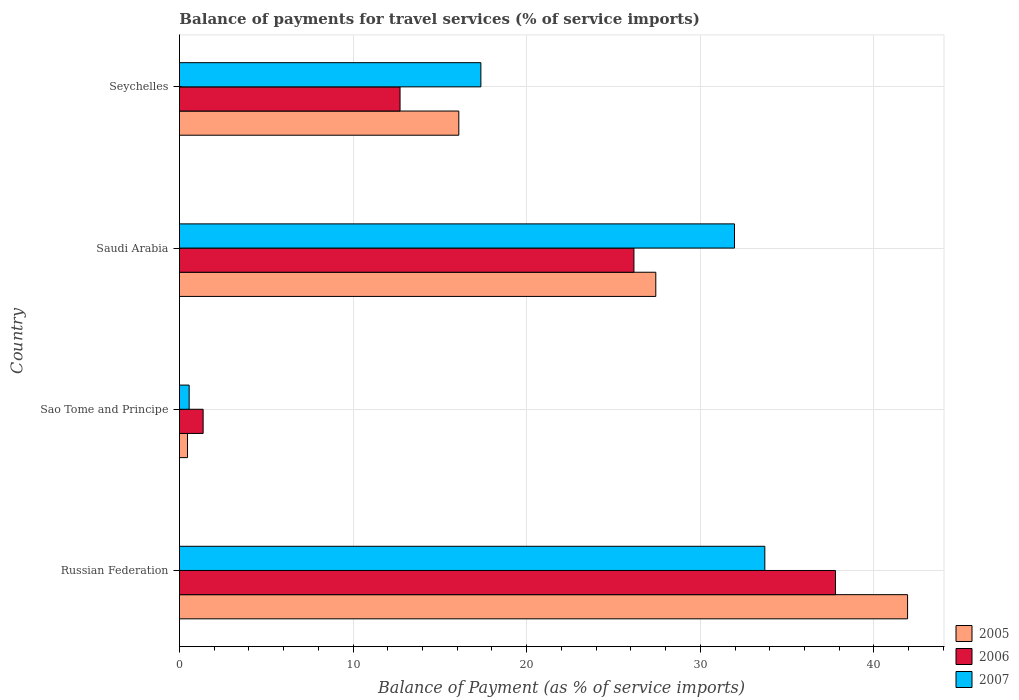How many groups of bars are there?
Keep it short and to the point. 4. Are the number of bars per tick equal to the number of legend labels?
Provide a short and direct response. Yes. Are the number of bars on each tick of the Y-axis equal?
Provide a succinct answer. Yes. How many bars are there on the 2nd tick from the top?
Offer a terse response. 3. How many bars are there on the 3rd tick from the bottom?
Ensure brevity in your answer.  3. What is the label of the 4th group of bars from the top?
Provide a succinct answer. Russian Federation. What is the balance of payments for travel services in 2006 in Russian Federation?
Ensure brevity in your answer.  37.78. Across all countries, what is the maximum balance of payments for travel services in 2007?
Ensure brevity in your answer.  33.72. Across all countries, what is the minimum balance of payments for travel services in 2005?
Make the answer very short. 0.47. In which country was the balance of payments for travel services in 2006 maximum?
Offer a terse response. Russian Federation. In which country was the balance of payments for travel services in 2007 minimum?
Provide a succinct answer. Sao Tome and Principe. What is the total balance of payments for travel services in 2006 in the graph?
Offer a very short reply. 78.03. What is the difference between the balance of payments for travel services in 2005 in Saudi Arabia and that in Seychelles?
Your answer should be compact. 11.34. What is the difference between the balance of payments for travel services in 2006 in Saudi Arabia and the balance of payments for travel services in 2007 in Sao Tome and Principe?
Your answer should be compact. 25.62. What is the average balance of payments for travel services in 2007 per country?
Your answer should be very brief. 20.9. What is the difference between the balance of payments for travel services in 2006 and balance of payments for travel services in 2005 in Sao Tome and Principe?
Your response must be concise. 0.9. In how many countries, is the balance of payments for travel services in 2007 greater than 26 %?
Keep it short and to the point. 2. What is the ratio of the balance of payments for travel services in 2007 in Saudi Arabia to that in Seychelles?
Your answer should be compact. 1.84. Is the balance of payments for travel services in 2006 in Russian Federation less than that in Seychelles?
Provide a short and direct response. No. Is the difference between the balance of payments for travel services in 2006 in Russian Federation and Sao Tome and Principe greater than the difference between the balance of payments for travel services in 2005 in Russian Federation and Sao Tome and Principe?
Keep it short and to the point. No. What is the difference between the highest and the second highest balance of payments for travel services in 2007?
Make the answer very short. 1.75. What is the difference between the highest and the lowest balance of payments for travel services in 2007?
Provide a short and direct response. 33.15. What does the 2nd bar from the top in Sao Tome and Principe represents?
Offer a very short reply. 2006. What does the 1st bar from the bottom in Russian Federation represents?
Give a very brief answer. 2005. Is it the case that in every country, the sum of the balance of payments for travel services in 2005 and balance of payments for travel services in 2007 is greater than the balance of payments for travel services in 2006?
Your answer should be very brief. No. How many bars are there?
Ensure brevity in your answer.  12. Are all the bars in the graph horizontal?
Your response must be concise. Yes. How many countries are there in the graph?
Ensure brevity in your answer.  4. Does the graph contain grids?
Provide a succinct answer. Yes. How are the legend labels stacked?
Make the answer very short. Vertical. What is the title of the graph?
Keep it short and to the point. Balance of payments for travel services (% of service imports). What is the label or title of the X-axis?
Give a very brief answer. Balance of Payment (as % of service imports). What is the Balance of Payment (as % of service imports) in 2005 in Russian Federation?
Provide a short and direct response. 41.94. What is the Balance of Payment (as % of service imports) in 2006 in Russian Federation?
Your answer should be very brief. 37.78. What is the Balance of Payment (as % of service imports) of 2007 in Russian Federation?
Your answer should be compact. 33.72. What is the Balance of Payment (as % of service imports) of 2005 in Sao Tome and Principe?
Keep it short and to the point. 0.47. What is the Balance of Payment (as % of service imports) in 2006 in Sao Tome and Principe?
Give a very brief answer. 1.37. What is the Balance of Payment (as % of service imports) in 2007 in Sao Tome and Principe?
Provide a succinct answer. 0.56. What is the Balance of Payment (as % of service imports) in 2005 in Saudi Arabia?
Make the answer very short. 27.44. What is the Balance of Payment (as % of service imports) of 2006 in Saudi Arabia?
Your answer should be compact. 26.18. What is the Balance of Payment (as % of service imports) of 2007 in Saudi Arabia?
Make the answer very short. 31.97. What is the Balance of Payment (as % of service imports) in 2005 in Seychelles?
Provide a short and direct response. 16.09. What is the Balance of Payment (as % of service imports) in 2006 in Seychelles?
Keep it short and to the point. 12.71. What is the Balance of Payment (as % of service imports) of 2007 in Seychelles?
Provide a short and direct response. 17.36. Across all countries, what is the maximum Balance of Payment (as % of service imports) in 2005?
Provide a succinct answer. 41.94. Across all countries, what is the maximum Balance of Payment (as % of service imports) of 2006?
Offer a very short reply. 37.78. Across all countries, what is the maximum Balance of Payment (as % of service imports) of 2007?
Keep it short and to the point. 33.72. Across all countries, what is the minimum Balance of Payment (as % of service imports) of 2005?
Provide a short and direct response. 0.47. Across all countries, what is the minimum Balance of Payment (as % of service imports) of 2006?
Make the answer very short. 1.37. Across all countries, what is the minimum Balance of Payment (as % of service imports) of 2007?
Your answer should be compact. 0.56. What is the total Balance of Payment (as % of service imports) in 2005 in the graph?
Ensure brevity in your answer.  85.93. What is the total Balance of Payment (as % of service imports) of 2006 in the graph?
Your response must be concise. 78.03. What is the total Balance of Payment (as % of service imports) of 2007 in the graph?
Ensure brevity in your answer.  83.61. What is the difference between the Balance of Payment (as % of service imports) in 2005 in Russian Federation and that in Sao Tome and Principe?
Your answer should be very brief. 41.47. What is the difference between the Balance of Payment (as % of service imports) of 2006 in Russian Federation and that in Sao Tome and Principe?
Your response must be concise. 36.42. What is the difference between the Balance of Payment (as % of service imports) in 2007 in Russian Federation and that in Sao Tome and Principe?
Offer a terse response. 33.15. What is the difference between the Balance of Payment (as % of service imports) of 2005 in Russian Federation and that in Saudi Arabia?
Give a very brief answer. 14.5. What is the difference between the Balance of Payment (as % of service imports) of 2006 in Russian Federation and that in Saudi Arabia?
Offer a terse response. 11.61. What is the difference between the Balance of Payment (as % of service imports) of 2007 in Russian Federation and that in Saudi Arabia?
Offer a very short reply. 1.75. What is the difference between the Balance of Payment (as % of service imports) of 2005 in Russian Federation and that in Seychelles?
Provide a succinct answer. 25.85. What is the difference between the Balance of Payment (as % of service imports) in 2006 in Russian Federation and that in Seychelles?
Provide a short and direct response. 25.08. What is the difference between the Balance of Payment (as % of service imports) in 2007 in Russian Federation and that in Seychelles?
Offer a terse response. 16.35. What is the difference between the Balance of Payment (as % of service imports) of 2005 in Sao Tome and Principe and that in Saudi Arabia?
Provide a succinct answer. -26.97. What is the difference between the Balance of Payment (as % of service imports) in 2006 in Sao Tome and Principe and that in Saudi Arabia?
Offer a very short reply. -24.81. What is the difference between the Balance of Payment (as % of service imports) of 2007 in Sao Tome and Principe and that in Saudi Arabia?
Provide a succinct answer. -31.41. What is the difference between the Balance of Payment (as % of service imports) of 2005 in Sao Tome and Principe and that in Seychelles?
Your answer should be very brief. -15.62. What is the difference between the Balance of Payment (as % of service imports) in 2006 in Sao Tome and Principe and that in Seychelles?
Provide a succinct answer. -11.34. What is the difference between the Balance of Payment (as % of service imports) of 2007 in Sao Tome and Principe and that in Seychelles?
Offer a very short reply. -16.8. What is the difference between the Balance of Payment (as % of service imports) in 2005 in Saudi Arabia and that in Seychelles?
Provide a succinct answer. 11.34. What is the difference between the Balance of Payment (as % of service imports) in 2006 in Saudi Arabia and that in Seychelles?
Keep it short and to the point. 13.47. What is the difference between the Balance of Payment (as % of service imports) in 2007 in Saudi Arabia and that in Seychelles?
Ensure brevity in your answer.  14.61. What is the difference between the Balance of Payment (as % of service imports) in 2005 in Russian Federation and the Balance of Payment (as % of service imports) in 2006 in Sao Tome and Principe?
Make the answer very short. 40.57. What is the difference between the Balance of Payment (as % of service imports) in 2005 in Russian Federation and the Balance of Payment (as % of service imports) in 2007 in Sao Tome and Principe?
Offer a terse response. 41.38. What is the difference between the Balance of Payment (as % of service imports) of 2006 in Russian Federation and the Balance of Payment (as % of service imports) of 2007 in Sao Tome and Principe?
Provide a succinct answer. 37.22. What is the difference between the Balance of Payment (as % of service imports) in 2005 in Russian Federation and the Balance of Payment (as % of service imports) in 2006 in Saudi Arabia?
Keep it short and to the point. 15.76. What is the difference between the Balance of Payment (as % of service imports) of 2005 in Russian Federation and the Balance of Payment (as % of service imports) of 2007 in Saudi Arabia?
Provide a succinct answer. 9.97. What is the difference between the Balance of Payment (as % of service imports) of 2006 in Russian Federation and the Balance of Payment (as % of service imports) of 2007 in Saudi Arabia?
Provide a succinct answer. 5.82. What is the difference between the Balance of Payment (as % of service imports) in 2005 in Russian Federation and the Balance of Payment (as % of service imports) in 2006 in Seychelles?
Offer a very short reply. 29.23. What is the difference between the Balance of Payment (as % of service imports) in 2005 in Russian Federation and the Balance of Payment (as % of service imports) in 2007 in Seychelles?
Provide a short and direct response. 24.58. What is the difference between the Balance of Payment (as % of service imports) in 2006 in Russian Federation and the Balance of Payment (as % of service imports) in 2007 in Seychelles?
Offer a terse response. 20.42. What is the difference between the Balance of Payment (as % of service imports) in 2005 in Sao Tome and Principe and the Balance of Payment (as % of service imports) in 2006 in Saudi Arabia?
Give a very brief answer. -25.71. What is the difference between the Balance of Payment (as % of service imports) in 2005 in Sao Tome and Principe and the Balance of Payment (as % of service imports) in 2007 in Saudi Arabia?
Offer a very short reply. -31.5. What is the difference between the Balance of Payment (as % of service imports) in 2006 in Sao Tome and Principe and the Balance of Payment (as % of service imports) in 2007 in Saudi Arabia?
Keep it short and to the point. -30.6. What is the difference between the Balance of Payment (as % of service imports) in 2005 in Sao Tome and Principe and the Balance of Payment (as % of service imports) in 2006 in Seychelles?
Your response must be concise. -12.24. What is the difference between the Balance of Payment (as % of service imports) of 2005 in Sao Tome and Principe and the Balance of Payment (as % of service imports) of 2007 in Seychelles?
Keep it short and to the point. -16.89. What is the difference between the Balance of Payment (as % of service imports) in 2006 in Sao Tome and Principe and the Balance of Payment (as % of service imports) in 2007 in Seychelles?
Give a very brief answer. -16. What is the difference between the Balance of Payment (as % of service imports) of 2005 in Saudi Arabia and the Balance of Payment (as % of service imports) of 2006 in Seychelles?
Offer a terse response. 14.73. What is the difference between the Balance of Payment (as % of service imports) in 2005 in Saudi Arabia and the Balance of Payment (as % of service imports) in 2007 in Seychelles?
Keep it short and to the point. 10.07. What is the difference between the Balance of Payment (as % of service imports) in 2006 in Saudi Arabia and the Balance of Payment (as % of service imports) in 2007 in Seychelles?
Your response must be concise. 8.82. What is the average Balance of Payment (as % of service imports) in 2005 per country?
Give a very brief answer. 21.48. What is the average Balance of Payment (as % of service imports) in 2006 per country?
Your answer should be compact. 19.51. What is the average Balance of Payment (as % of service imports) of 2007 per country?
Provide a succinct answer. 20.9. What is the difference between the Balance of Payment (as % of service imports) of 2005 and Balance of Payment (as % of service imports) of 2006 in Russian Federation?
Your answer should be compact. 4.15. What is the difference between the Balance of Payment (as % of service imports) of 2005 and Balance of Payment (as % of service imports) of 2007 in Russian Federation?
Give a very brief answer. 8.22. What is the difference between the Balance of Payment (as % of service imports) of 2006 and Balance of Payment (as % of service imports) of 2007 in Russian Federation?
Ensure brevity in your answer.  4.07. What is the difference between the Balance of Payment (as % of service imports) of 2005 and Balance of Payment (as % of service imports) of 2006 in Sao Tome and Principe?
Your answer should be compact. -0.9. What is the difference between the Balance of Payment (as % of service imports) of 2005 and Balance of Payment (as % of service imports) of 2007 in Sao Tome and Principe?
Provide a succinct answer. -0.09. What is the difference between the Balance of Payment (as % of service imports) in 2006 and Balance of Payment (as % of service imports) in 2007 in Sao Tome and Principe?
Provide a succinct answer. 0.8. What is the difference between the Balance of Payment (as % of service imports) in 2005 and Balance of Payment (as % of service imports) in 2006 in Saudi Arabia?
Ensure brevity in your answer.  1.26. What is the difference between the Balance of Payment (as % of service imports) of 2005 and Balance of Payment (as % of service imports) of 2007 in Saudi Arabia?
Give a very brief answer. -4.53. What is the difference between the Balance of Payment (as % of service imports) in 2006 and Balance of Payment (as % of service imports) in 2007 in Saudi Arabia?
Your answer should be very brief. -5.79. What is the difference between the Balance of Payment (as % of service imports) of 2005 and Balance of Payment (as % of service imports) of 2006 in Seychelles?
Provide a succinct answer. 3.38. What is the difference between the Balance of Payment (as % of service imports) of 2005 and Balance of Payment (as % of service imports) of 2007 in Seychelles?
Provide a short and direct response. -1.27. What is the difference between the Balance of Payment (as % of service imports) of 2006 and Balance of Payment (as % of service imports) of 2007 in Seychelles?
Keep it short and to the point. -4.65. What is the ratio of the Balance of Payment (as % of service imports) in 2005 in Russian Federation to that in Sao Tome and Principe?
Your response must be concise. 89.84. What is the ratio of the Balance of Payment (as % of service imports) of 2006 in Russian Federation to that in Sao Tome and Principe?
Make the answer very short. 27.67. What is the ratio of the Balance of Payment (as % of service imports) in 2007 in Russian Federation to that in Sao Tome and Principe?
Make the answer very short. 60.06. What is the ratio of the Balance of Payment (as % of service imports) of 2005 in Russian Federation to that in Saudi Arabia?
Your answer should be very brief. 1.53. What is the ratio of the Balance of Payment (as % of service imports) in 2006 in Russian Federation to that in Saudi Arabia?
Give a very brief answer. 1.44. What is the ratio of the Balance of Payment (as % of service imports) of 2007 in Russian Federation to that in Saudi Arabia?
Ensure brevity in your answer.  1.05. What is the ratio of the Balance of Payment (as % of service imports) in 2005 in Russian Federation to that in Seychelles?
Your response must be concise. 2.61. What is the ratio of the Balance of Payment (as % of service imports) in 2006 in Russian Federation to that in Seychelles?
Make the answer very short. 2.97. What is the ratio of the Balance of Payment (as % of service imports) of 2007 in Russian Federation to that in Seychelles?
Ensure brevity in your answer.  1.94. What is the ratio of the Balance of Payment (as % of service imports) of 2005 in Sao Tome and Principe to that in Saudi Arabia?
Offer a very short reply. 0.02. What is the ratio of the Balance of Payment (as % of service imports) in 2006 in Sao Tome and Principe to that in Saudi Arabia?
Make the answer very short. 0.05. What is the ratio of the Balance of Payment (as % of service imports) of 2007 in Sao Tome and Principe to that in Saudi Arabia?
Your response must be concise. 0.02. What is the ratio of the Balance of Payment (as % of service imports) in 2005 in Sao Tome and Principe to that in Seychelles?
Ensure brevity in your answer.  0.03. What is the ratio of the Balance of Payment (as % of service imports) in 2006 in Sao Tome and Principe to that in Seychelles?
Your answer should be compact. 0.11. What is the ratio of the Balance of Payment (as % of service imports) of 2007 in Sao Tome and Principe to that in Seychelles?
Make the answer very short. 0.03. What is the ratio of the Balance of Payment (as % of service imports) of 2005 in Saudi Arabia to that in Seychelles?
Give a very brief answer. 1.71. What is the ratio of the Balance of Payment (as % of service imports) of 2006 in Saudi Arabia to that in Seychelles?
Keep it short and to the point. 2.06. What is the ratio of the Balance of Payment (as % of service imports) of 2007 in Saudi Arabia to that in Seychelles?
Give a very brief answer. 1.84. What is the difference between the highest and the second highest Balance of Payment (as % of service imports) in 2005?
Offer a terse response. 14.5. What is the difference between the highest and the second highest Balance of Payment (as % of service imports) in 2006?
Offer a very short reply. 11.61. What is the difference between the highest and the second highest Balance of Payment (as % of service imports) of 2007?
Make the answer very short. 1.75. What is the difference between the highest and the lowest Balance of Payment (as % of service imports) of 2005?
Keep it short and to the point. 41.47. What is the difference between the highest and the lowest Balance of Payment (as % of service imports) of 2006?
Ensure brevity in your answer.  36.42. What is the difference between the highest and the lowest Balance of Payment (as % of service imports) of 2007?
Offer a very short reply. 33.15. 